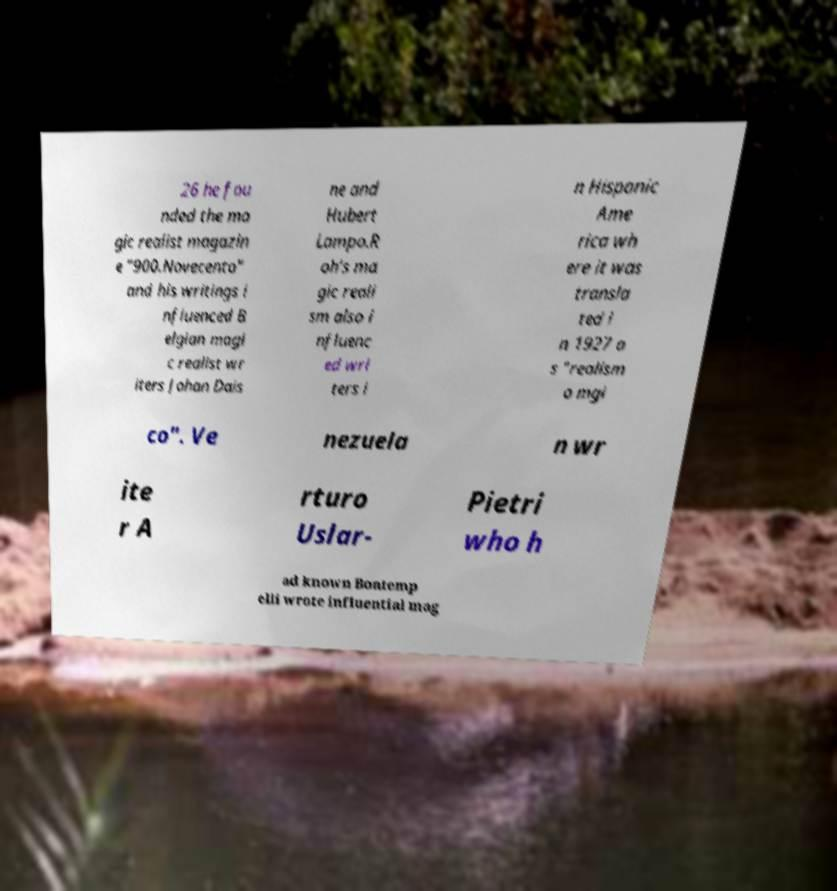Please identify and transcribe the text found in this image. 26 he fou nded the ma gic realist magazin e "900.Novecento" and his writings i nfluenced B elgian magi c realist wr iters Johan Dais ne and Hubert Lampo.R oh's ma gic reali sm also i nfluenc ed wri ters i n Hispanic Ame rica wh ere it was transla ted i n 1927 a s "realism o mgi co". Ve nezuela n wr ite r A rturo Uslar- Pietri who h ad known Bontemp elli wrote influential mag 